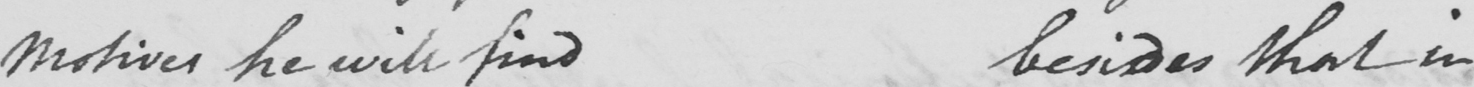What text is written in this handwritten line? motives he will find besides that in 